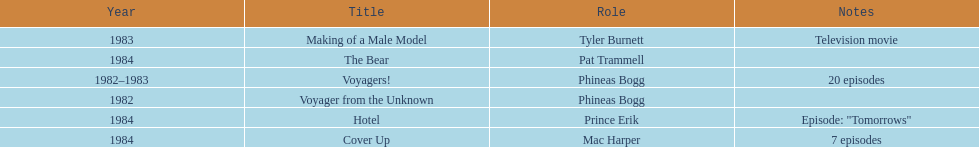In how many titles on this list did he not play the role of phineas bogg? 4. 